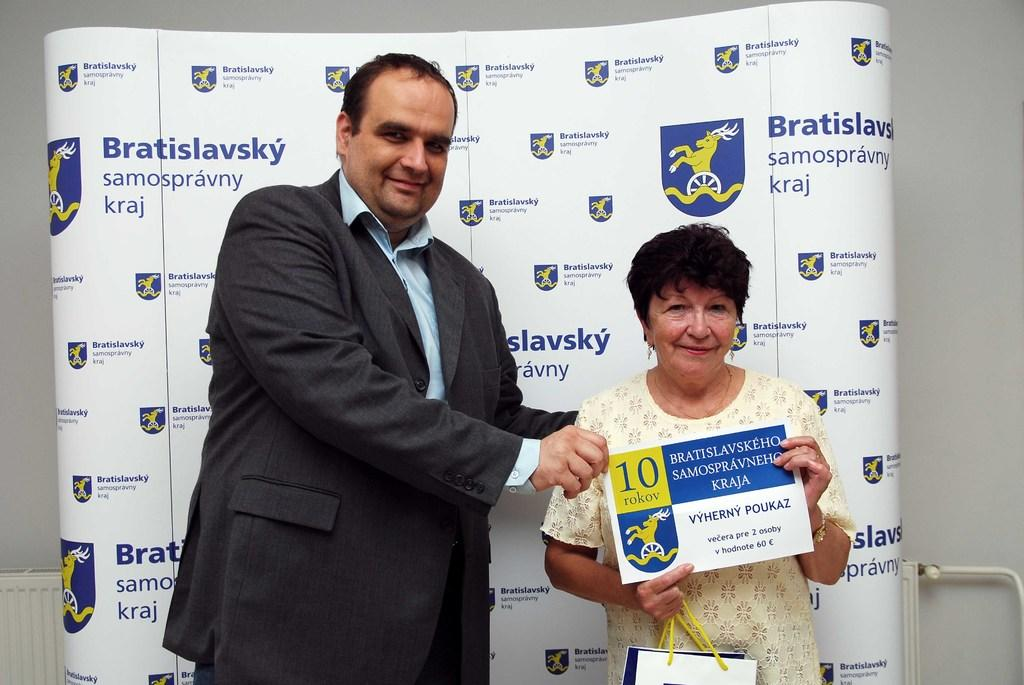How many people are present in the image? There are two people standing in the image. What are the two people holding? The two people are holding a poster. Can you describe the woman in the image? The woman is holding a bag. What can be seen in the background of the image? There is a banner visible in the background, and there is also a wall. What type of jam is being discovered by the people in the image? There is no jam or discovery present in the image; it features two people holding a poster and a woman holding a bag. How many knots are visible in the image? There are no knots visible in the image. 